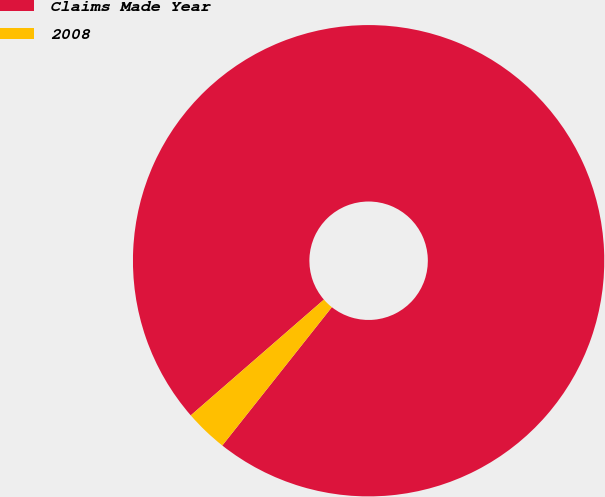<chart> <loc_0><loc_0><loc_500><loc_500><pie_chart><fcel>Claims Made Year<fcel>2008<nl><fcel>97.05%<fcel>2.95%<nl></chart> 